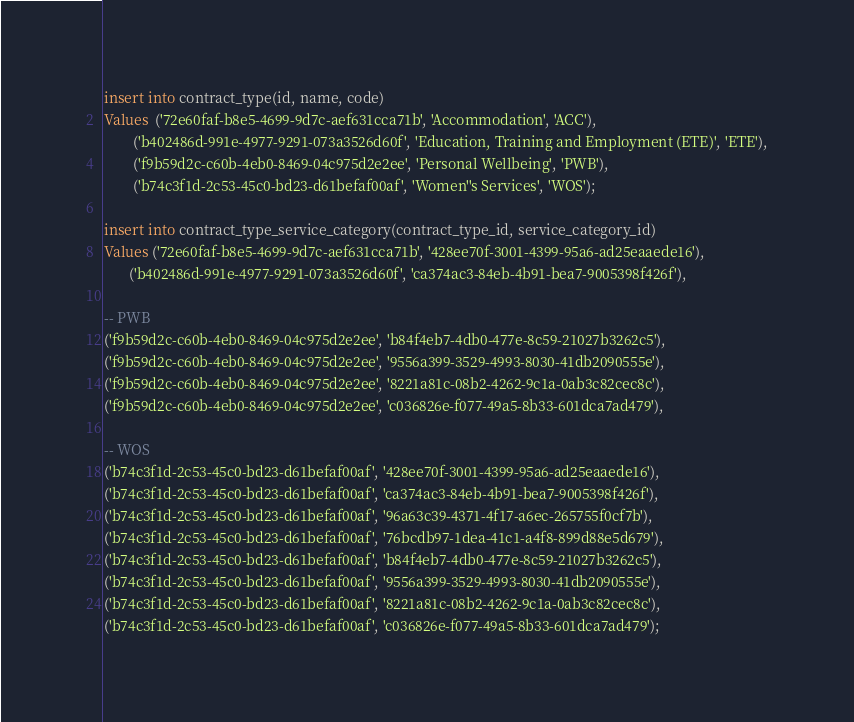Convert code to text. <code><loc_0><loc_0><loc_500><loc_500><_SQL_>insert into contract_type(id, name, code)
Values  ('72e60faf-b8e5-4699-9d7c-aef631cca71b', 'Accommodation', 'ACC'),
        ('b402486d-991e-4977-9291-073a3526d60f', 'Education, Training and Employment (ETE)', 'ETE'),
        ('f9b59d2c-c60b-4eb0-8469-04c975d2e2ee', 'Personal Wellbeing', 'PWB'),
        ('b74c3f1d-2c53-45c0-bd23-d61befaf00af', 'Women''s Services', 'WOS');

insert into contract_type_service_category(contract_type_id, service_category_id)
Values ('72e60faf-b8e5-4699-9d7c-aef631cca71b', '428ee70f-3001-4399-95a6-ad25eaaede16'),
       ('b402486d-991e-4977-9291-073a3526d60f', 'ca374ac3-84eb-4b91-bea7-9005398f426f'),

-- PWB
('f9b59d2c-c60b-4eb0-8469-04c975d2e2ee', 'b84f4eb7-4db0-477e-8c59-21027b3262c5'),
('f9b59d2c-c60b-4eb0-8469-04c975d2e2ee', '9556a399-3529-4993-8030-41db2090555e'),
('f9b59d2c-c60b-4eb0-8469-04c975d2e2ee', '8221a81c-08b2-4262-9c1a-0ab3c82cec8c'),
('f9b59d2c-c60b-4eb0-8469-04c975d2e2ee', 'c036826e-f077-49a5-8b33-601dca7ad479'),

-- WOS
('b74c3f1d-2c53-45c0-bd23-d61befaf00af', '428ee70f-3001-4399-95a6-ad25eaaede16'),
('b74c3f1d-2c53-45c0-bd23-d61befaf00af', 'ca374ac3-84eb-4b91-bea7-9005398f426f'),
('b74c3f1d-2c53-45c0-bd23-d61befaf00af', '96a63c39-4371-4f17-a6ec-265755f0cf7b'),
('b74c3f1d-2c53-45c0-bd23-d61befaf00af', '76bcdb97-1dea-41c1-a4f8-899d88e5d679'),
('b74c3f1d-2c53-45c0-bd23-d61befaf00af', 'b84f4eb7-4db0-477e-8c59-21027b3262c5'),
('b74c3f1d-2c53-45c0-bd23-d61befaf00af', '9556a399-3529-4993-8030-41db2090555e'),
('b74c3f1d-2c53-45c0-bd23-d61befaf00af', '8221a81c-08b2-4262-9c1a-0ab3c82cec8c'),
('b74c3f1d-2c53-45c0-bd23-d61befaf00af', 'c036826e-f077-49a5-8b33-601dca7ad479');
</code> 